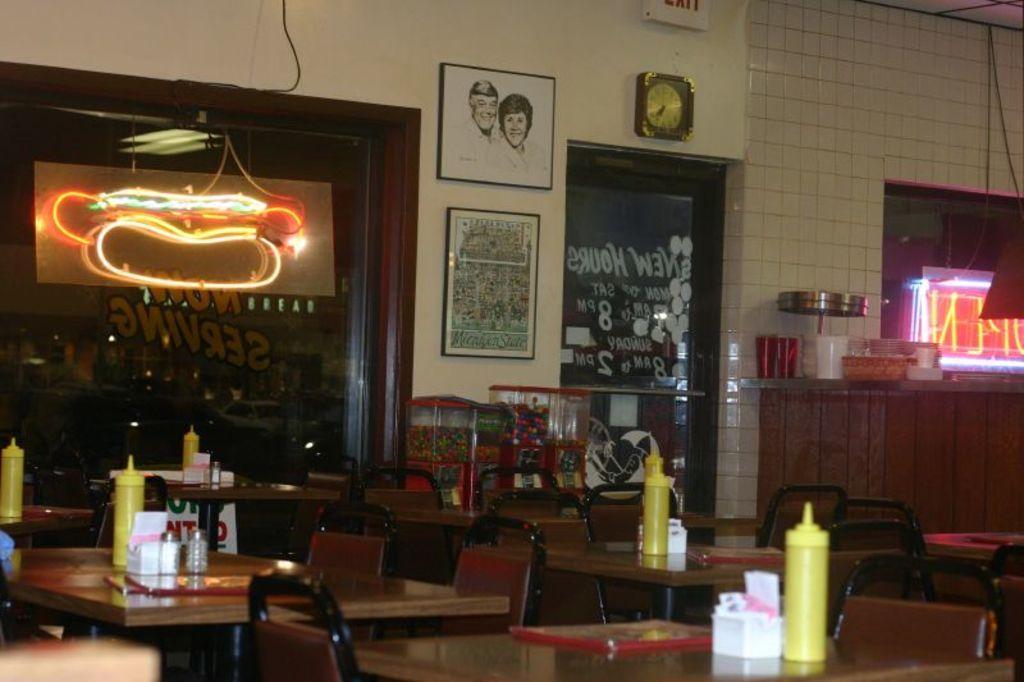Can you describe this image briefly? This image is taken in the store. In this image there are tables and chairs. We can see bottles and shakers placed on the tables. There are containers. On the right we can see a countertop and there are things placed on the counter top. There are doors and we can see lights. There are frames placed on the walls. 